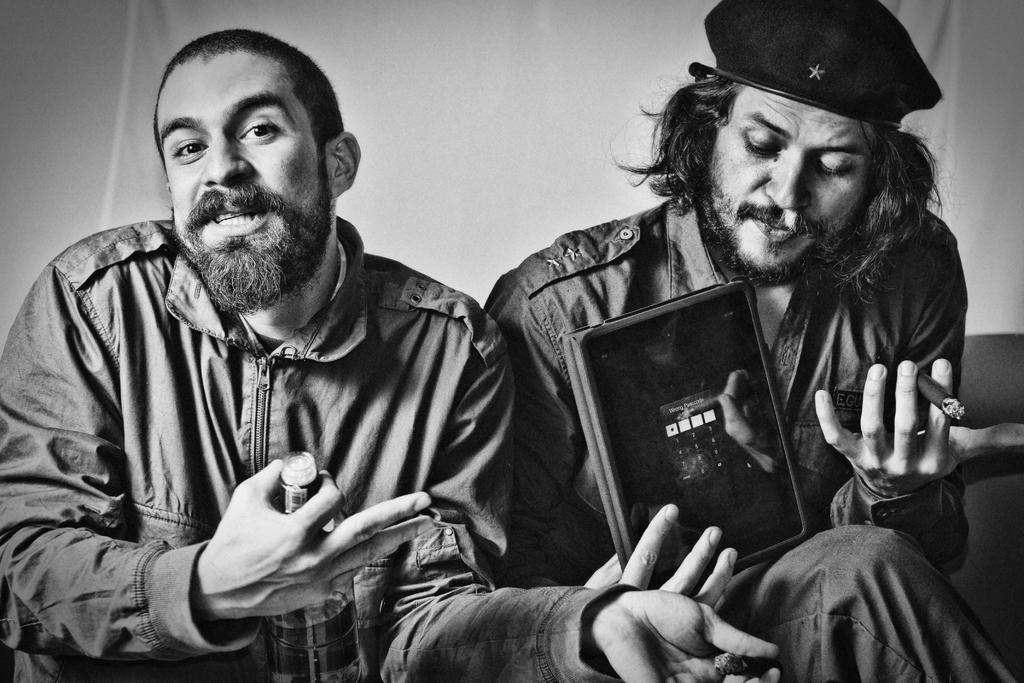How many people are in the image? There are two persons in the image. What are the persons doing in the image? The persons are sitting. What objects are being held by the persons? One person is holding a bottle, one person is holding a book, and one person is holding a cigarette. What type of covering is visible in the image? There is a curtain visible in the image. What type of grass can be seen growing in the image? There is no grass visible in the image. What kind of bread is being eaten by the person holding the book? There is no bread present in the image. 